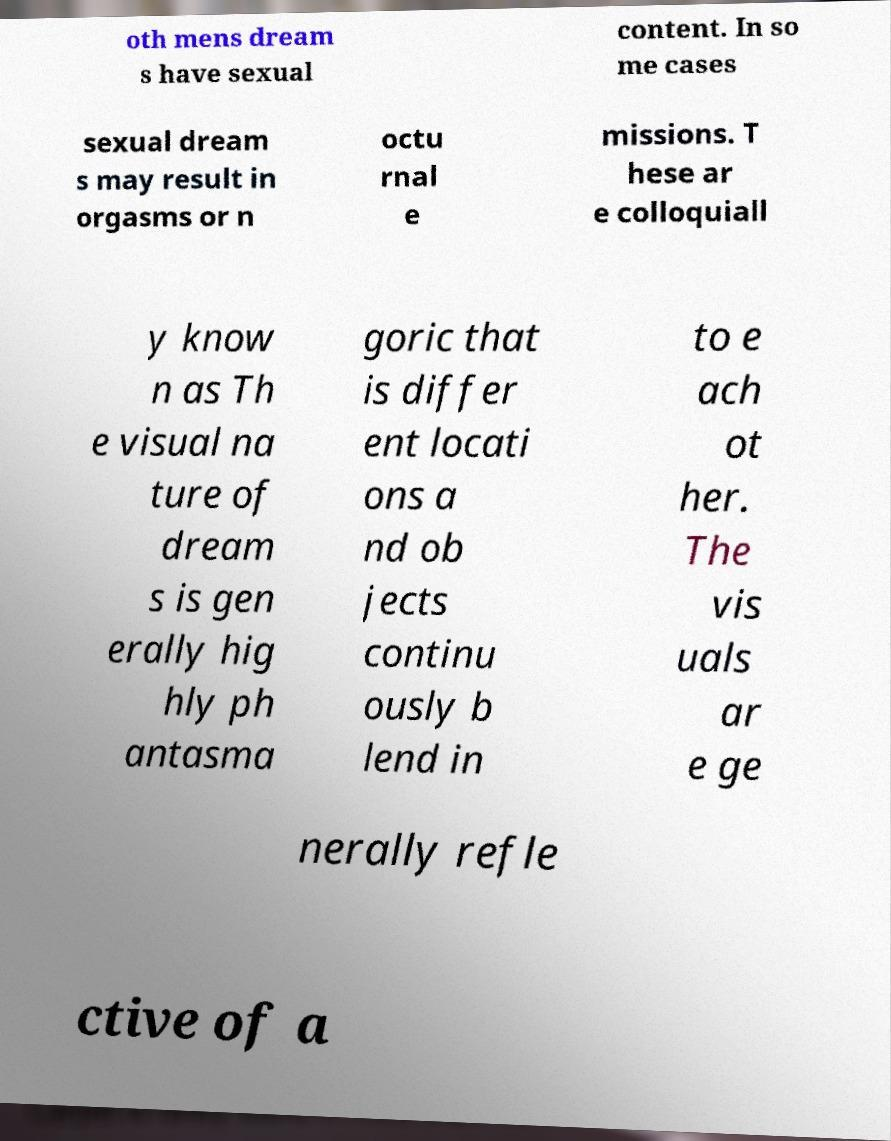Can you read and provide the text displayed in the image?This photo seems to have some interesting text. Can you extract and type it out for me? oth mens dream s have sexual content. In so me cases sexual dream s may result in orgasms or n octu rnal e missions. T hese ar e colloquiall y know n as Th e visual na ture of dream s is gen erally hig hly ph antasma goric that is differ ent locati ons a nd ob jects continu ously b lend in to e ach ot her. The vis uals ar e ge nerally refle ctive of a 